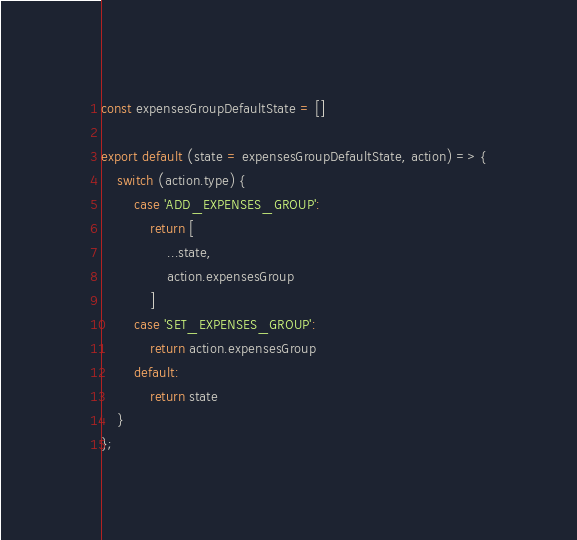Convert code to text. <code><loc_0><loc_0><loc_500><loc_500><_JavaScript_>const expensesGroupDefaultState = []

export default (state = expensesGroupDefaultState, action) => {
    switch (action.type) {
        case 'ADD_EXPENSES_GROUP':
            return [
                ...state,
                action.expensesGroup
            ]
        case 'SET_EXPENSES_GROUP':
            return action.expensesGroup
        default:
            return state
    }
};</code> 